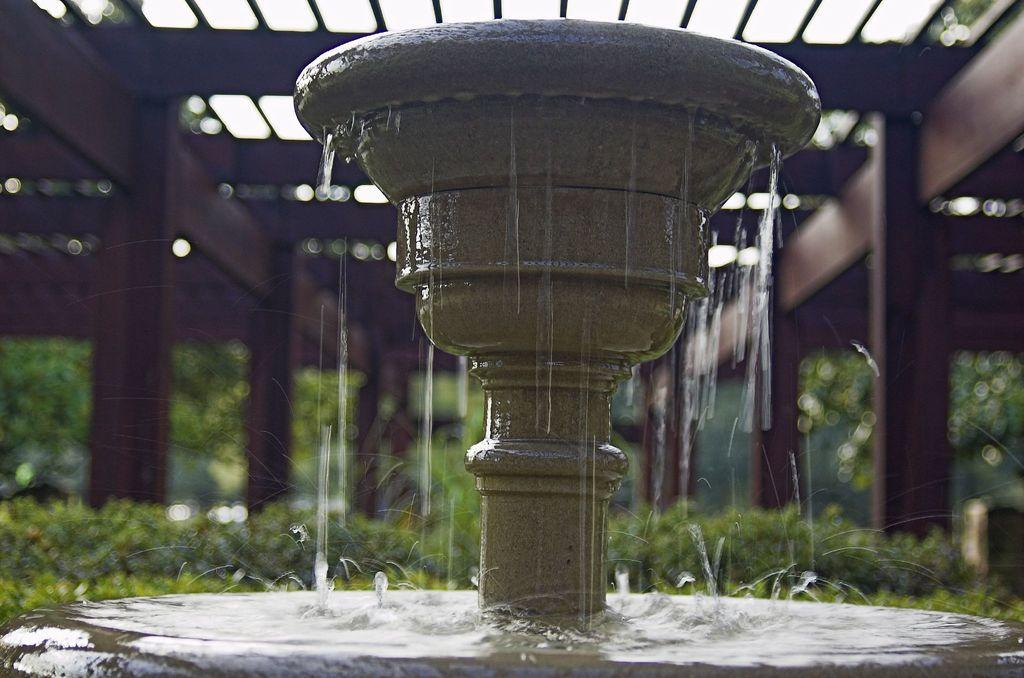What is the main feature in the image? There is a water fountain in the image. What other natural elements can be seen in the image? There are plants and trees in the image. What type of ceiling is present in the image? There is a wooden ceiling in the image. How far is the knot tied on the tree from the water fountain in the image? There is no knot tied on a tree in the image, so it is not possible to determine the distance between it and the water fountain. 